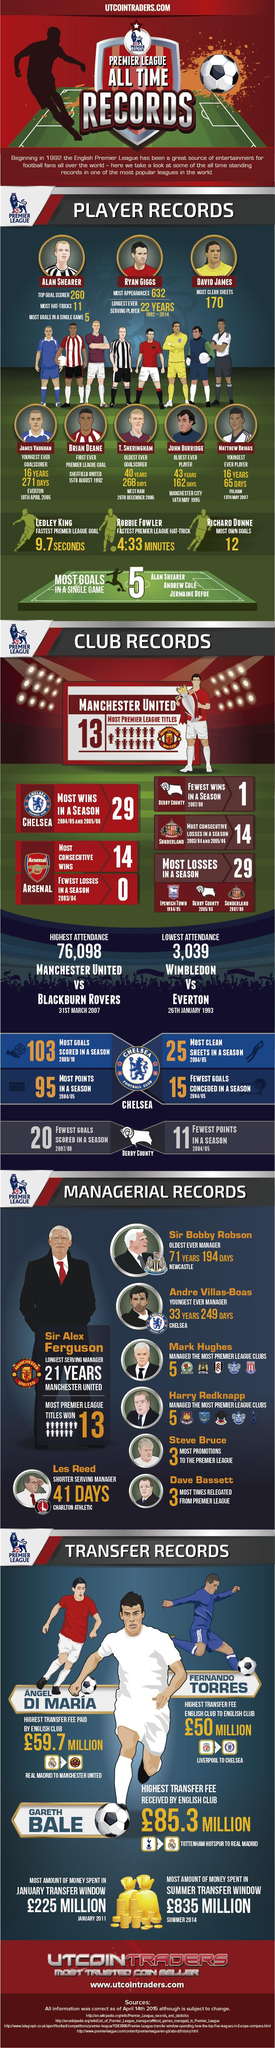List a handful of essential elements in this visual. Alan Shearer holds the records for being the top goal scorer with 260 goals, having achieved the most hat-tricks with 11, and scoring the most goals in a single game with 5. Matthew Briggs is the youngest ever player. Arsenal holds the club records for most consecutive wins with 14 victories in a row, and for having the fewest losses in a season with only two losses during the 2003/2004 campaign. The fastest Premier League goal was scored in just 9.7 seconds. John Burridge is the oldest player. 